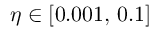Convert formula to latex. <formula><loc_0><loc_0><loc_500><loc_500>\eta \in [ 0 . 0 0 1 , \, 0 . 1 ]</formula> 